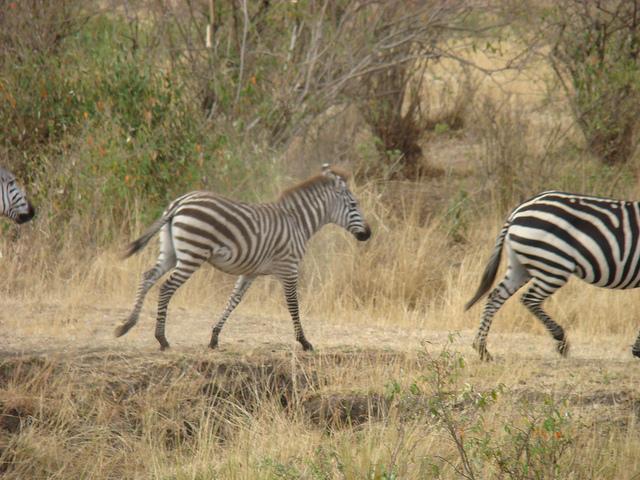Are all the zebras fully visible?
Answer briefly. No. What direction are the zebras facing?
Keep it brief. Right. What color is the zebra's mane?
Keep it brief. Brown. What are the zebra doing?
Be succinct. Running. 